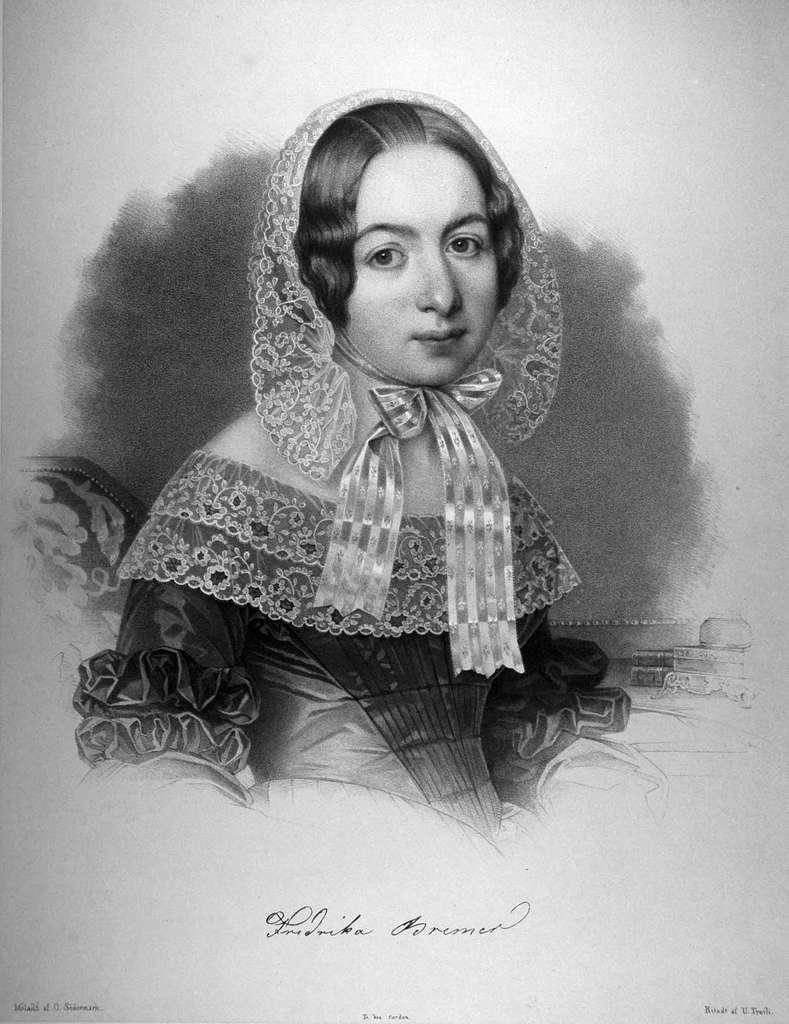What is depicted in the image? There is a sketch of a lady in the image. What additional information is present on the sketch? There is text written on the sketch. What type of sign is present in the image? There is no sign present in the image; it features a sketch of a lady with text written on it. What is the current status of the lady's development in the image? The image is a sketch, so it does not depict the lady's development or any current status. 